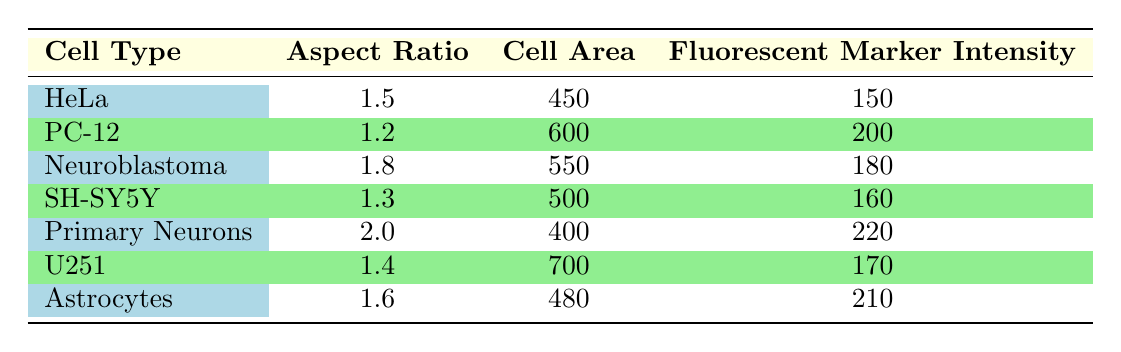What is the fluorescent marker intensity for Primary Neurons? The table shows that for Primary Neurons, the fluorescent marker intensity is listed as 220.
Answer: 220 Which cell type has the highest aspect ratio? The aspect ratios for each cell type are as follows: HeLa (1.5), PC-12 (1.2), Neuroblastoma (1.8), SH-SY5Y (1.3), Primary Neurons (2.0), U251 (1.4), and Astrocytes (1.6). The highest value is for Primary Neurons at 2.0.
Answer: Primary Neurons What is the average cell area of all listed cell types? The cell areas are: 450, 600, 550, 500, 400, 700, and 480. Adding these gives a total of 3780. There are 7 cell types, so the average is 3780 / 7 = 540.
Answer: 540 Is the fluorescent marker intensity of Astrocytes greater than that of HeLa? The fluorescent marker intensity for Astrocytes is 210, while for HeLa it is 150. Since 210 is greater than 150, the statement is true.
Answer: Yes What is the difference in cell area between the largest and smallest cell types? The largest cell area is 700 (U251) and the smallest is 400 (Primary Neurons). The difference is 700 - 400 = 300.
Answer: 300 